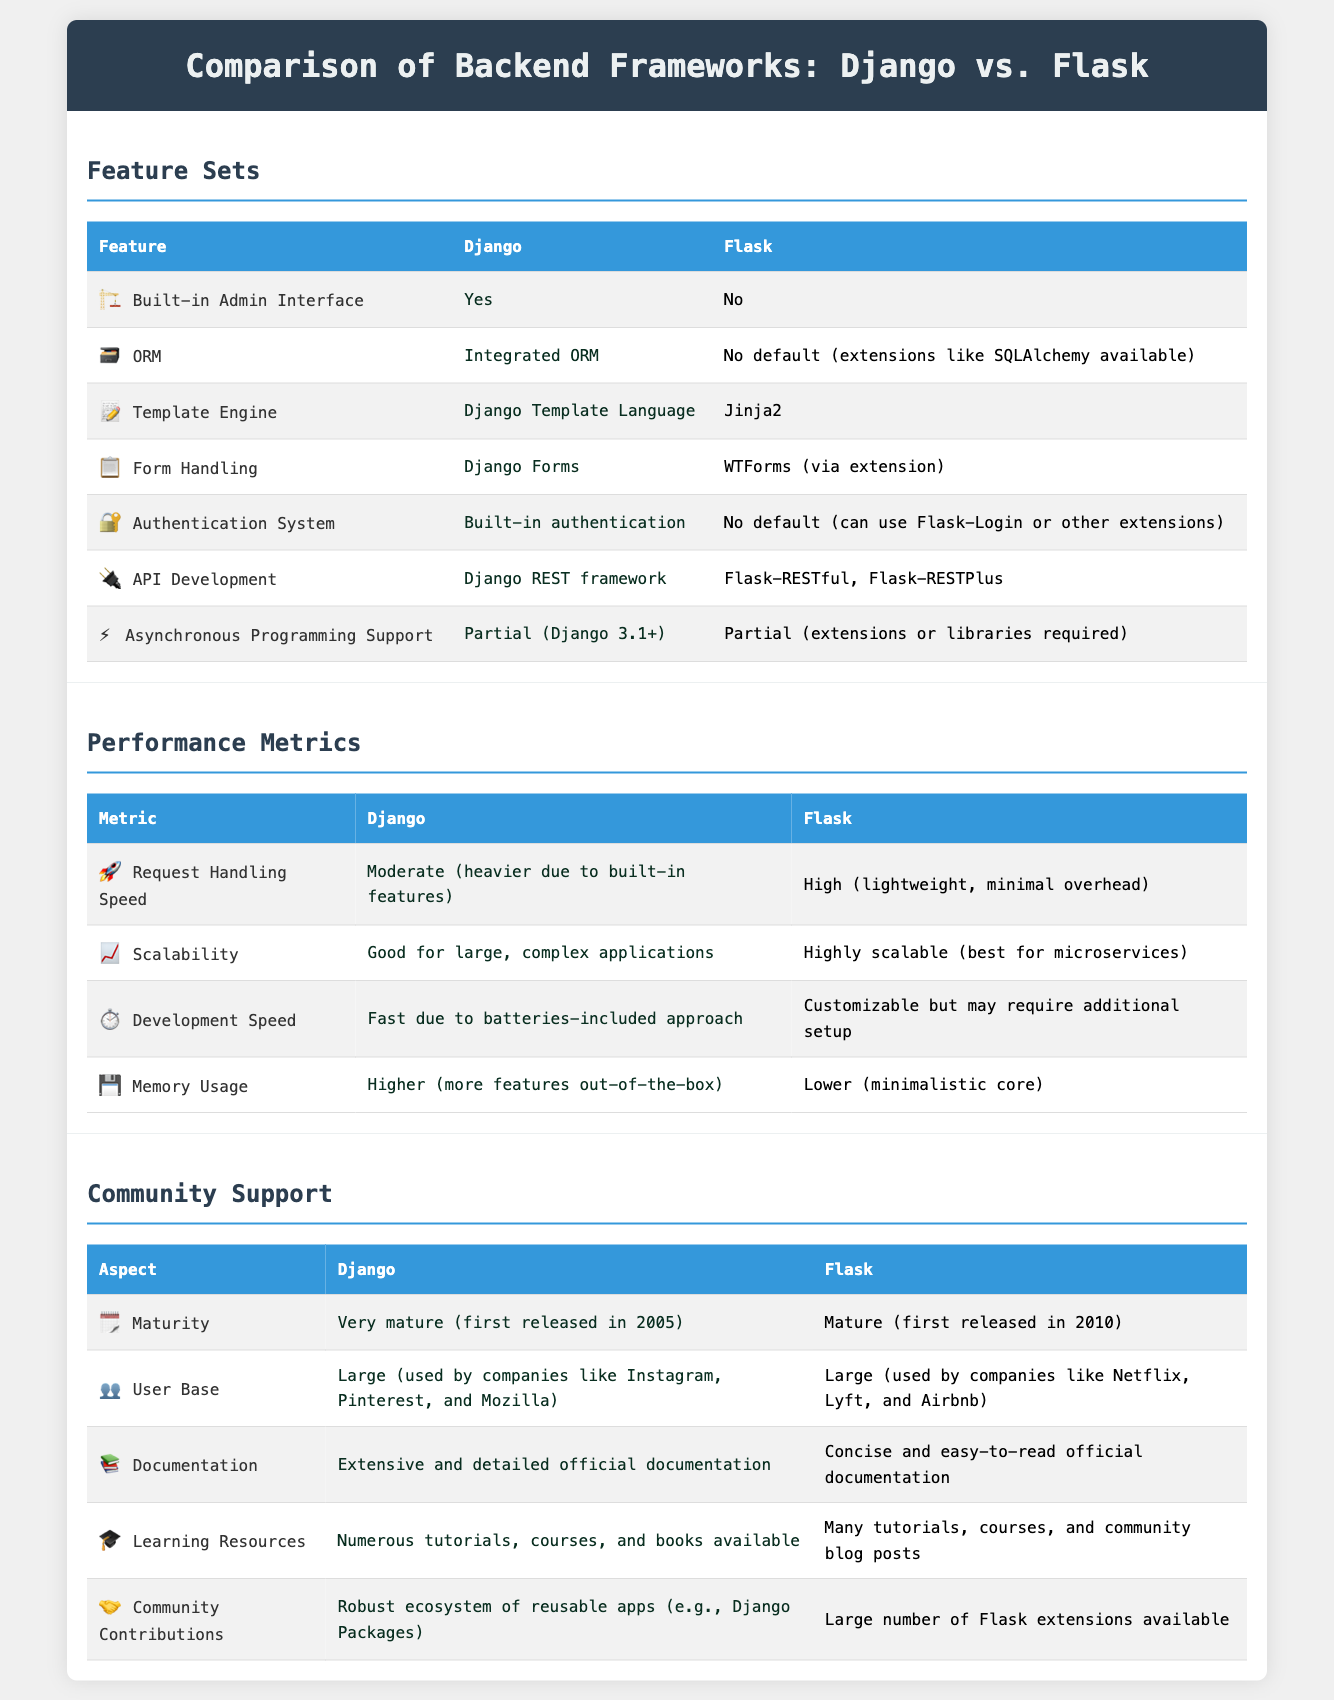What built-in feature does Django have that Flask does not? The document states that Django has a "Built-in Admin Interface," while Flask does not have this feature.
Answer: Yes Which ORM support does Django provide? According to the document, Django provides an "Integrated ORM," while Flask has no default ORM support but can use extensions like SQLAlchemy.
Answer: Integrated ORM What is the request handling speed for Flask? The document describes Flask's request handling speed as "High," indicating that it has minimal overhead compared to Django.
Answer: High Which framework offers a more extensive documentation? The document highlights Django's documentation as "Extensive and detailed," while Flask's documentation is described as "Concise and easy-to-read."
Answer: Extensive and detailed Which framework is better suited for microservices? The document mentions that Flask is "Highly scalable (best for microservices)," while Django is noted for its good scalability in large, complex applications.
Answer: Highly scalable When was Django first released? The document indicates that Django was first released in 2005, making it a very mature framework.
Answer: 2005 What community contributions does Django have? The document states that Django has a "Robust ecosystem of reusable apps (e.g., Django Packages)," emphasizing its strong community contributions.
Answer: Robust ecosystem of reusable apps Which framework provides a built-in authentication system? The document specifies that Django has a "Built-in authentication" system, whereas Flask requires extensions for authentication.
Answer: Built-in authentication What is the scalability of Django? According to the document, Django is described as having "Good for large, complex applications," providing insight into its scalability.
Answer: Good for large, complex applications 